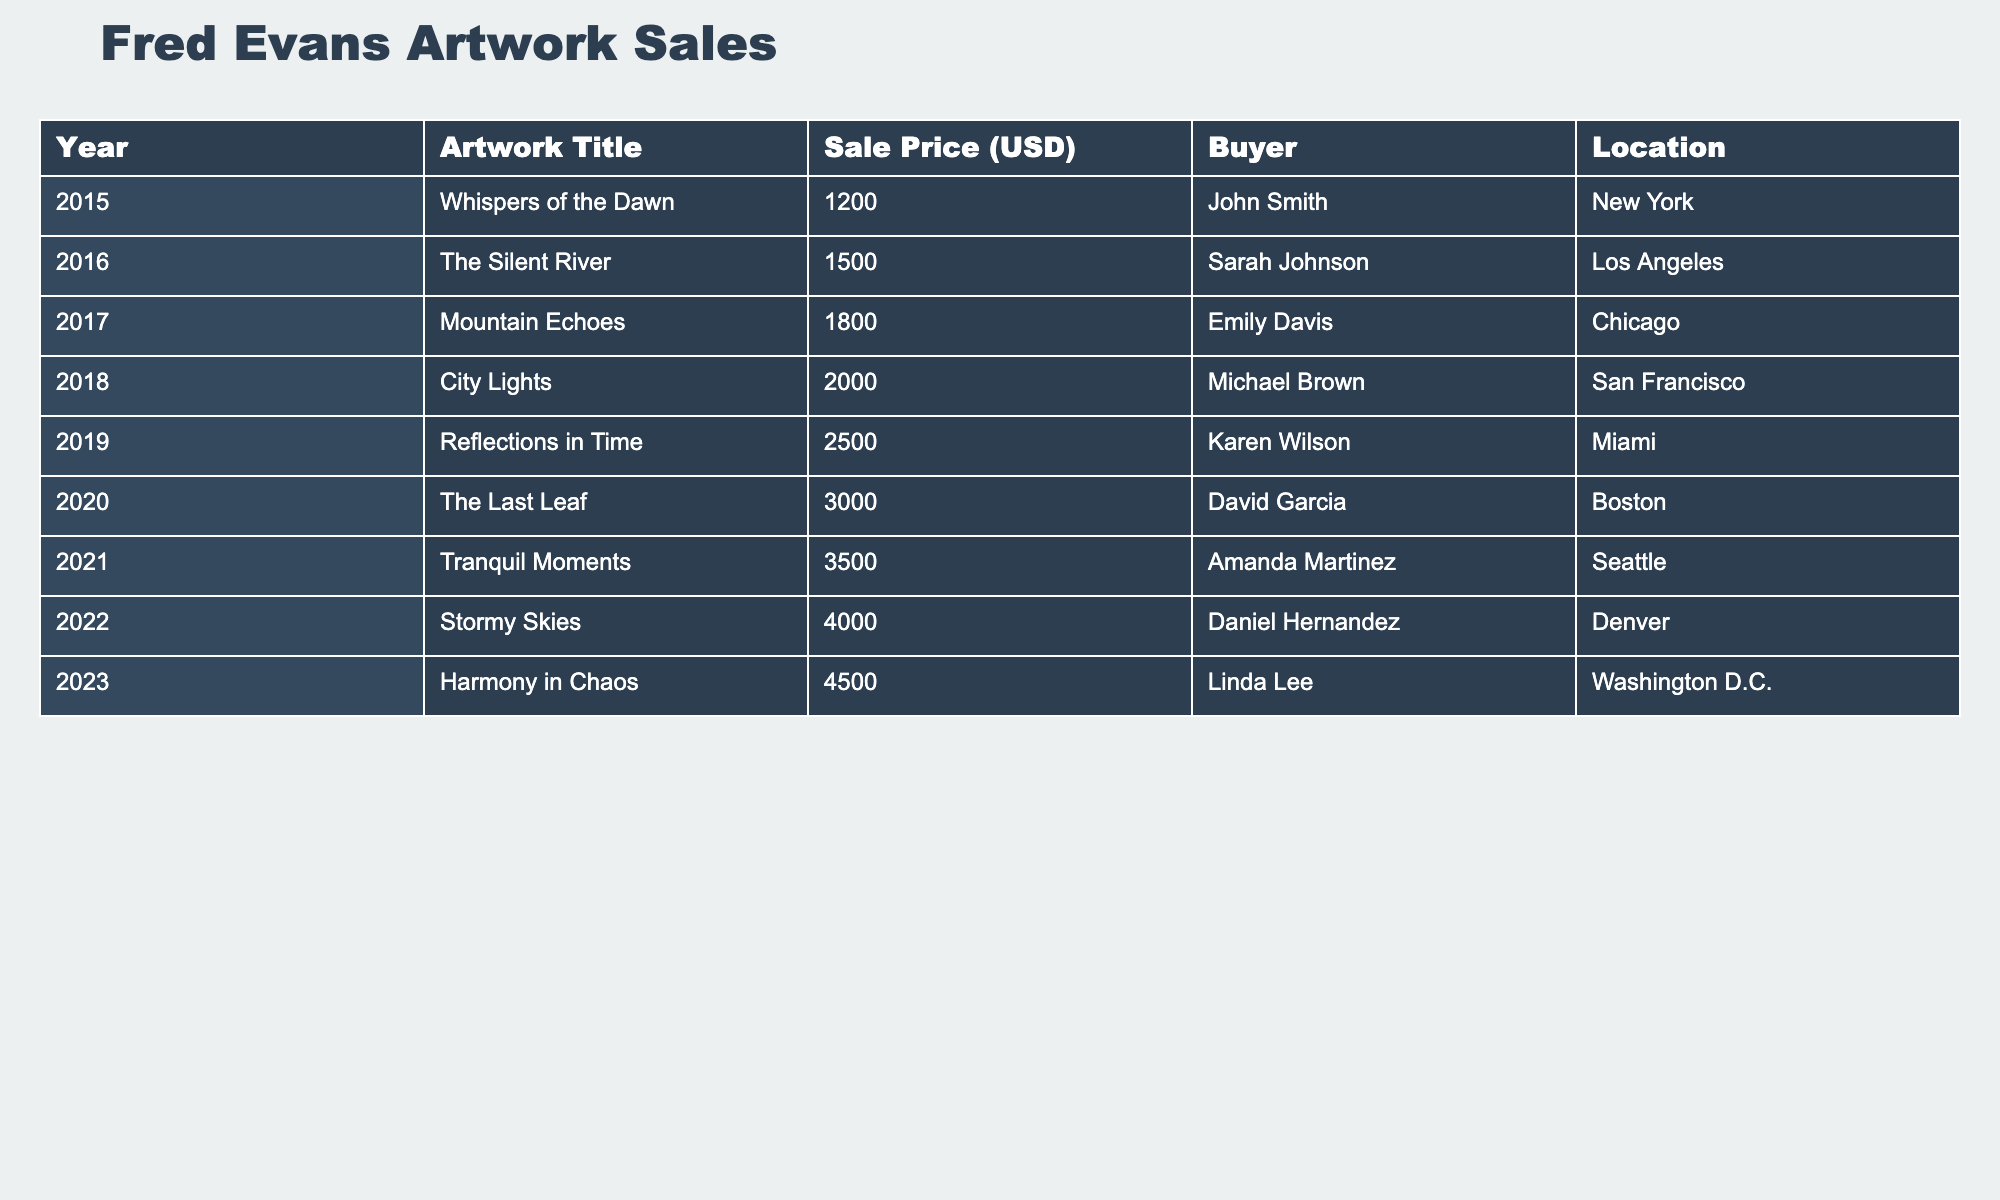What was the sale price of "Stormy Skies"? The table lists "Stormy Skies" under the year 2022 with a sale price of 4000 USD.
Answer: 4000 USD Who bought "Harmony in Chaos"? According to the table, "Harmony in Chaos," sold in 2023, was purchased by Linda Lee.
Answer: Linda Lee What is the total sale price of all artworks from 2015 to 2023? To find the total sale price, we add the individual prices: 1200 + 1500 + 1800 + 2000 + 2500 + 3000 + 3500 + 4000 + 4500 = 22500 USD.
Answer: 22500 USD Which artwork was sold for the highest price? By examining the sale prices in the table, the artwork "Harmony in Chaos" from 2023 was sold for the highest price of 4500 USD.
Answer: Harmony in Chaos How much more did "Reflections in Time" sell for compared to "The Last Leaf"? The sale price of "Reflections in Time" is 2500 USD, while "The Last Leaf" sold for 3000 USD. The difference is 3000 - 2500 = 500 USD.
Answer: 500 USD Did any artwork sell for less than 1500 USD? Checking the sale prices in the table, all artworks from 2015 to 2023 have sale prices starting at 1200 USD, which is less than 1500 USD. Therefore, the answer is true.
Answer: Yes What was the average sale price from 2015 to 2023? To calculate the average, total the sale prices (22500 USD) and divide by the number of artworks (9): 22500 / 9 = 2500 USD.
Answer: 2500 USD Which locations featured buyers for Fred Evans' artworks in 2022 and 2023? From the table, in 2022, the buyer was in Denver, and in 2023, the buyer was in Washington D.C.
Answer: Denver and Washington D.C Which year saw the most significant single-year increase in sale price compared to the previous year? The largest increase occurs from 2022 to 2023, where the price goes from 4000 to 4500 USD, an increase of 500 USD. No other year exceeds this amount when comparing to the prior year.
Answer: 2022 to 2023 What was the total number of buyers who purchased artworks? The table shows a unique buyer for each year from 2015 to 2023, resulting in a total of 9 unique buyers.
Answer: 9 buyers 